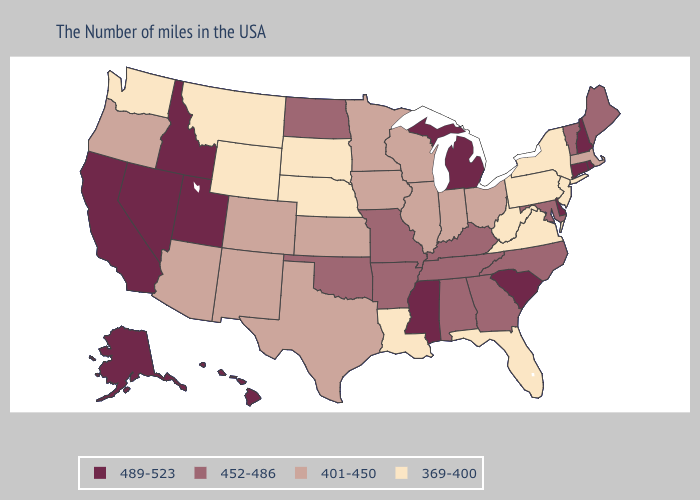What is the value of Minnesota?
Concise answer only. 401-450. What is the lowest value in the Northeast?
Concise answer only. 369-400. Does Connecticut have the highest value in the Northeast?
Be succinct. Yes. Among the states that border Pennsylvania , does Maryland have the lowest value?
Keep it brief. No. Which states hav the highest value in the Northeast?
Give a very brief answer. Rhode Island, New Hampshire, Connecticut. Name the states that have a value in the range 452-486?
Be succinct. Maine, Vermont, Maryland, North Carolina, Georgia, Kentucky, Alabama, Tennessee, Missouri, Arkansas, Oklahoma, North Dakota. Among the states that border Kentucky , which have the lowest value?
Quick response, please. Virginia, West Virginia. Does the first symbol in the legend represent the smallest category?
Give a very brief answer. No. What is the lowest value in the USA?
Be succinct. 369-400. Which states have the lowest value in the MidWest?
Write a very short answer. Nebraska, South Dakota. How many symbols are there in the legend?
Write a very short answer. 4. Which states have the highest value in the USA?
Short answer required. Rhode Island, New Hampshire, Connecticut, Delaware, South Carolina, Michigan, Mississippi, Utah, Idaho, Nevada, California, Alaska, Hawaii. What is the value of Virginia?
Quick response, please. 369-400. What is the value of Montana?
Be succinct. 369-400. Name the states that have a value in the range 401-450?
Keep it brief. Massachusetts, Ohio, Indiana, Wisconsin, Illinois, Minnesota, Iowa, Kansas, Texas, Colorado, New Mexico, Arizona, Oregon. 